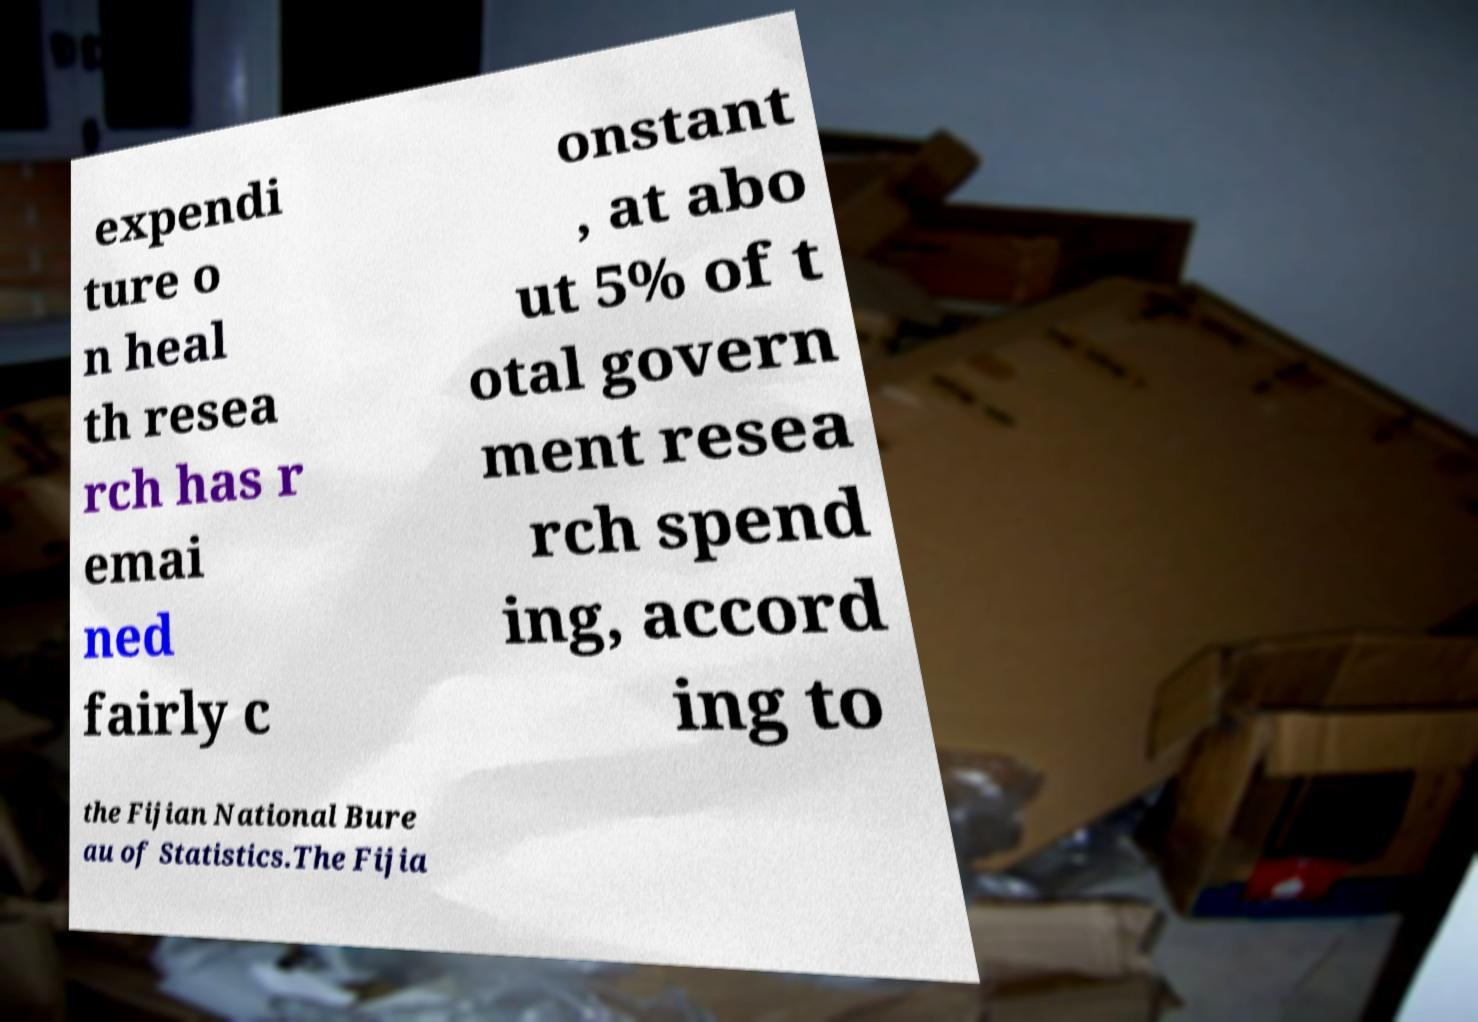Can you read and provide the text displayed in the image?This photo seems to have some interesting text. Can you extract and type it out for me? expendi ture o n heal th resea rch has r emai ned fairly c onstant , at abo ut 5% of t otal govern ment resea rch spend ing, accord ing to the Fijian National Bure au of Statistics.The Fijia 